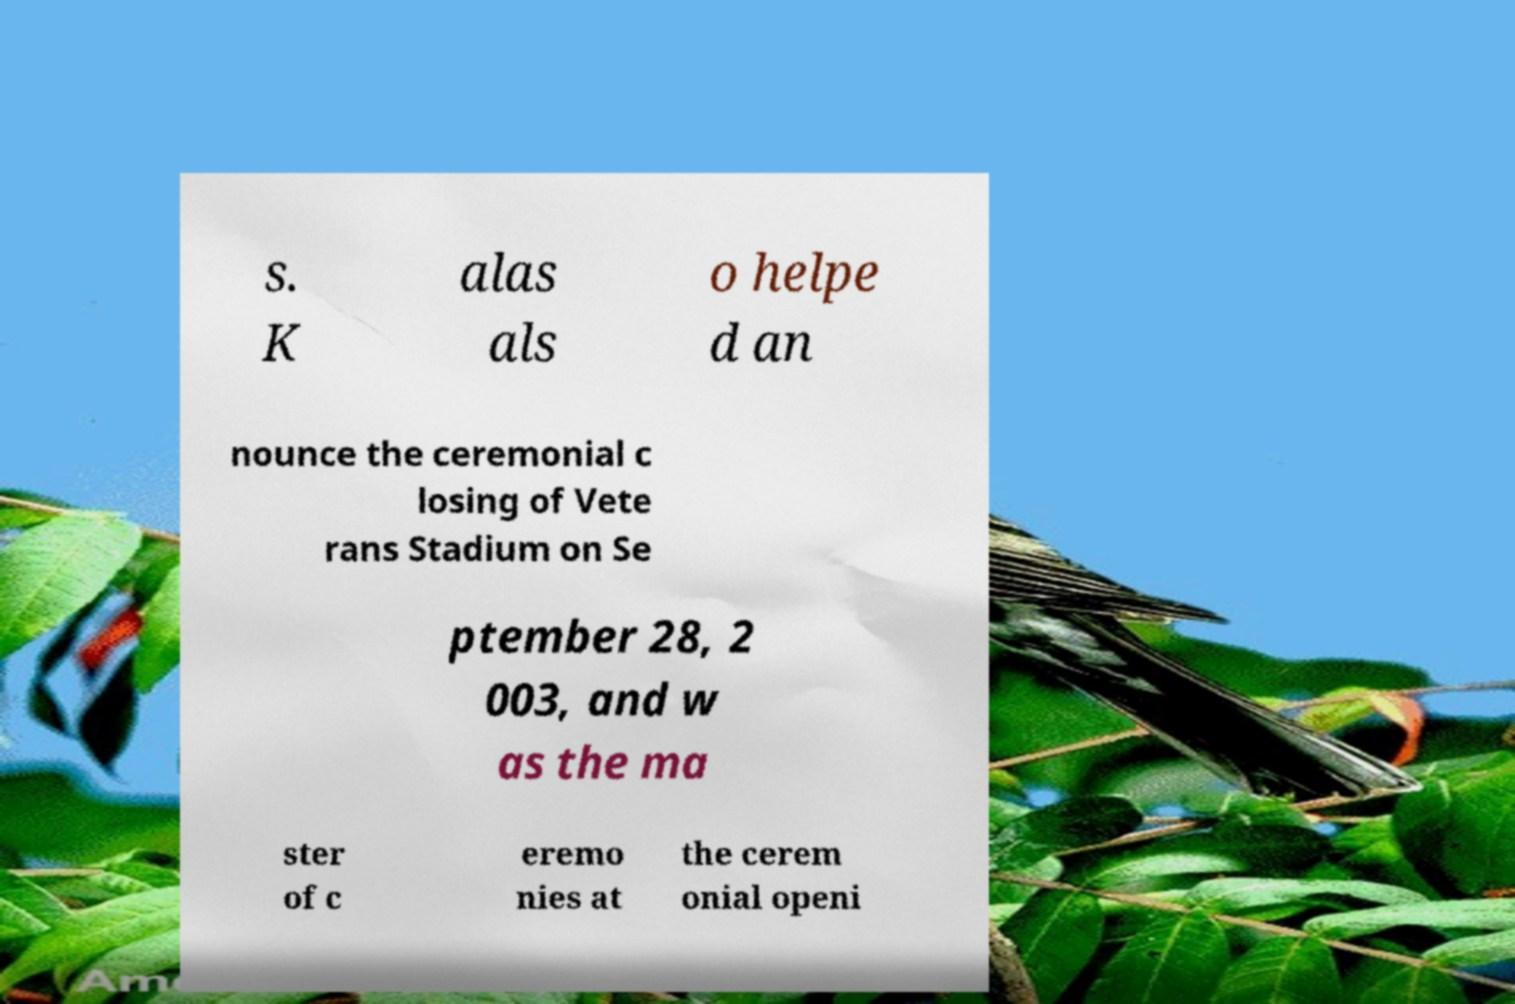There's text embedded in this image that I need extracted. Can you transcribe it verbatim? s. K alas als o helpe d an nounce the ceremonial c losing of Vete rans Stadium on Se ptember 28, 2 003, and w as the ma ster of c eremo nies at the cerem onial openi 